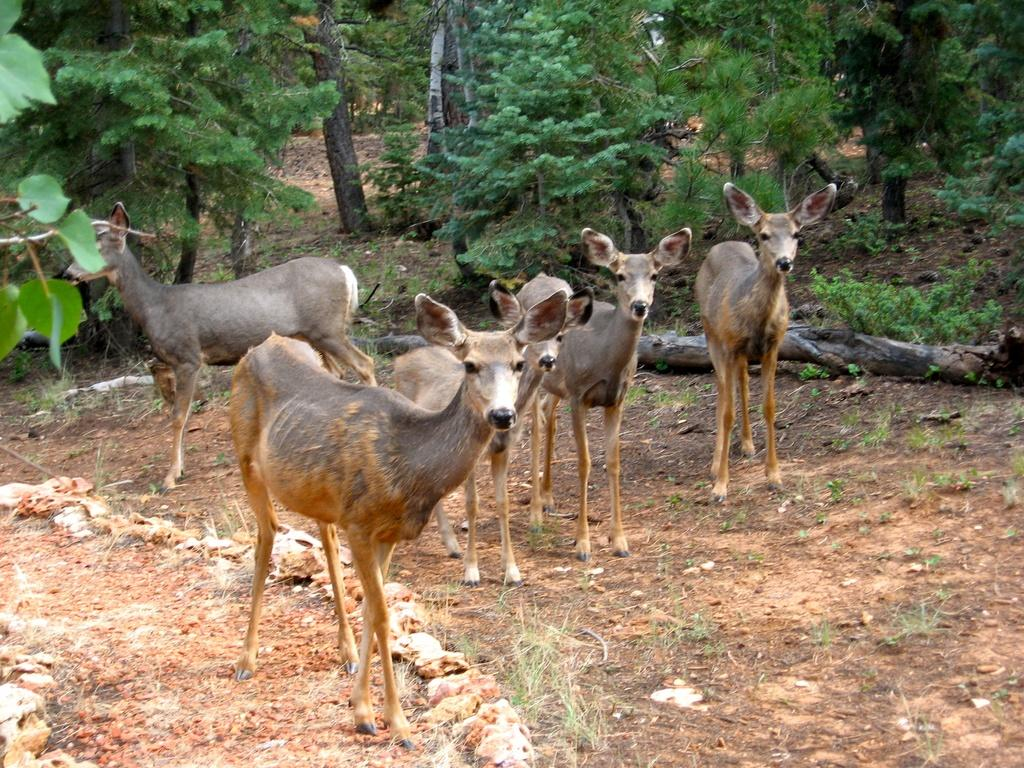What is the main subject of the image? The main subject of the image is a herd. Can you describe the position of the herd in the image? The herd is standing on the ground. What can be seen in the background of the image? There are trees and logs in the background of the image. What title does the herd hold in the image? There is no title associated with the herd in the image. What nation do the members of the herd belong to in the image? The image does not provide information about the nationality of the herd. 